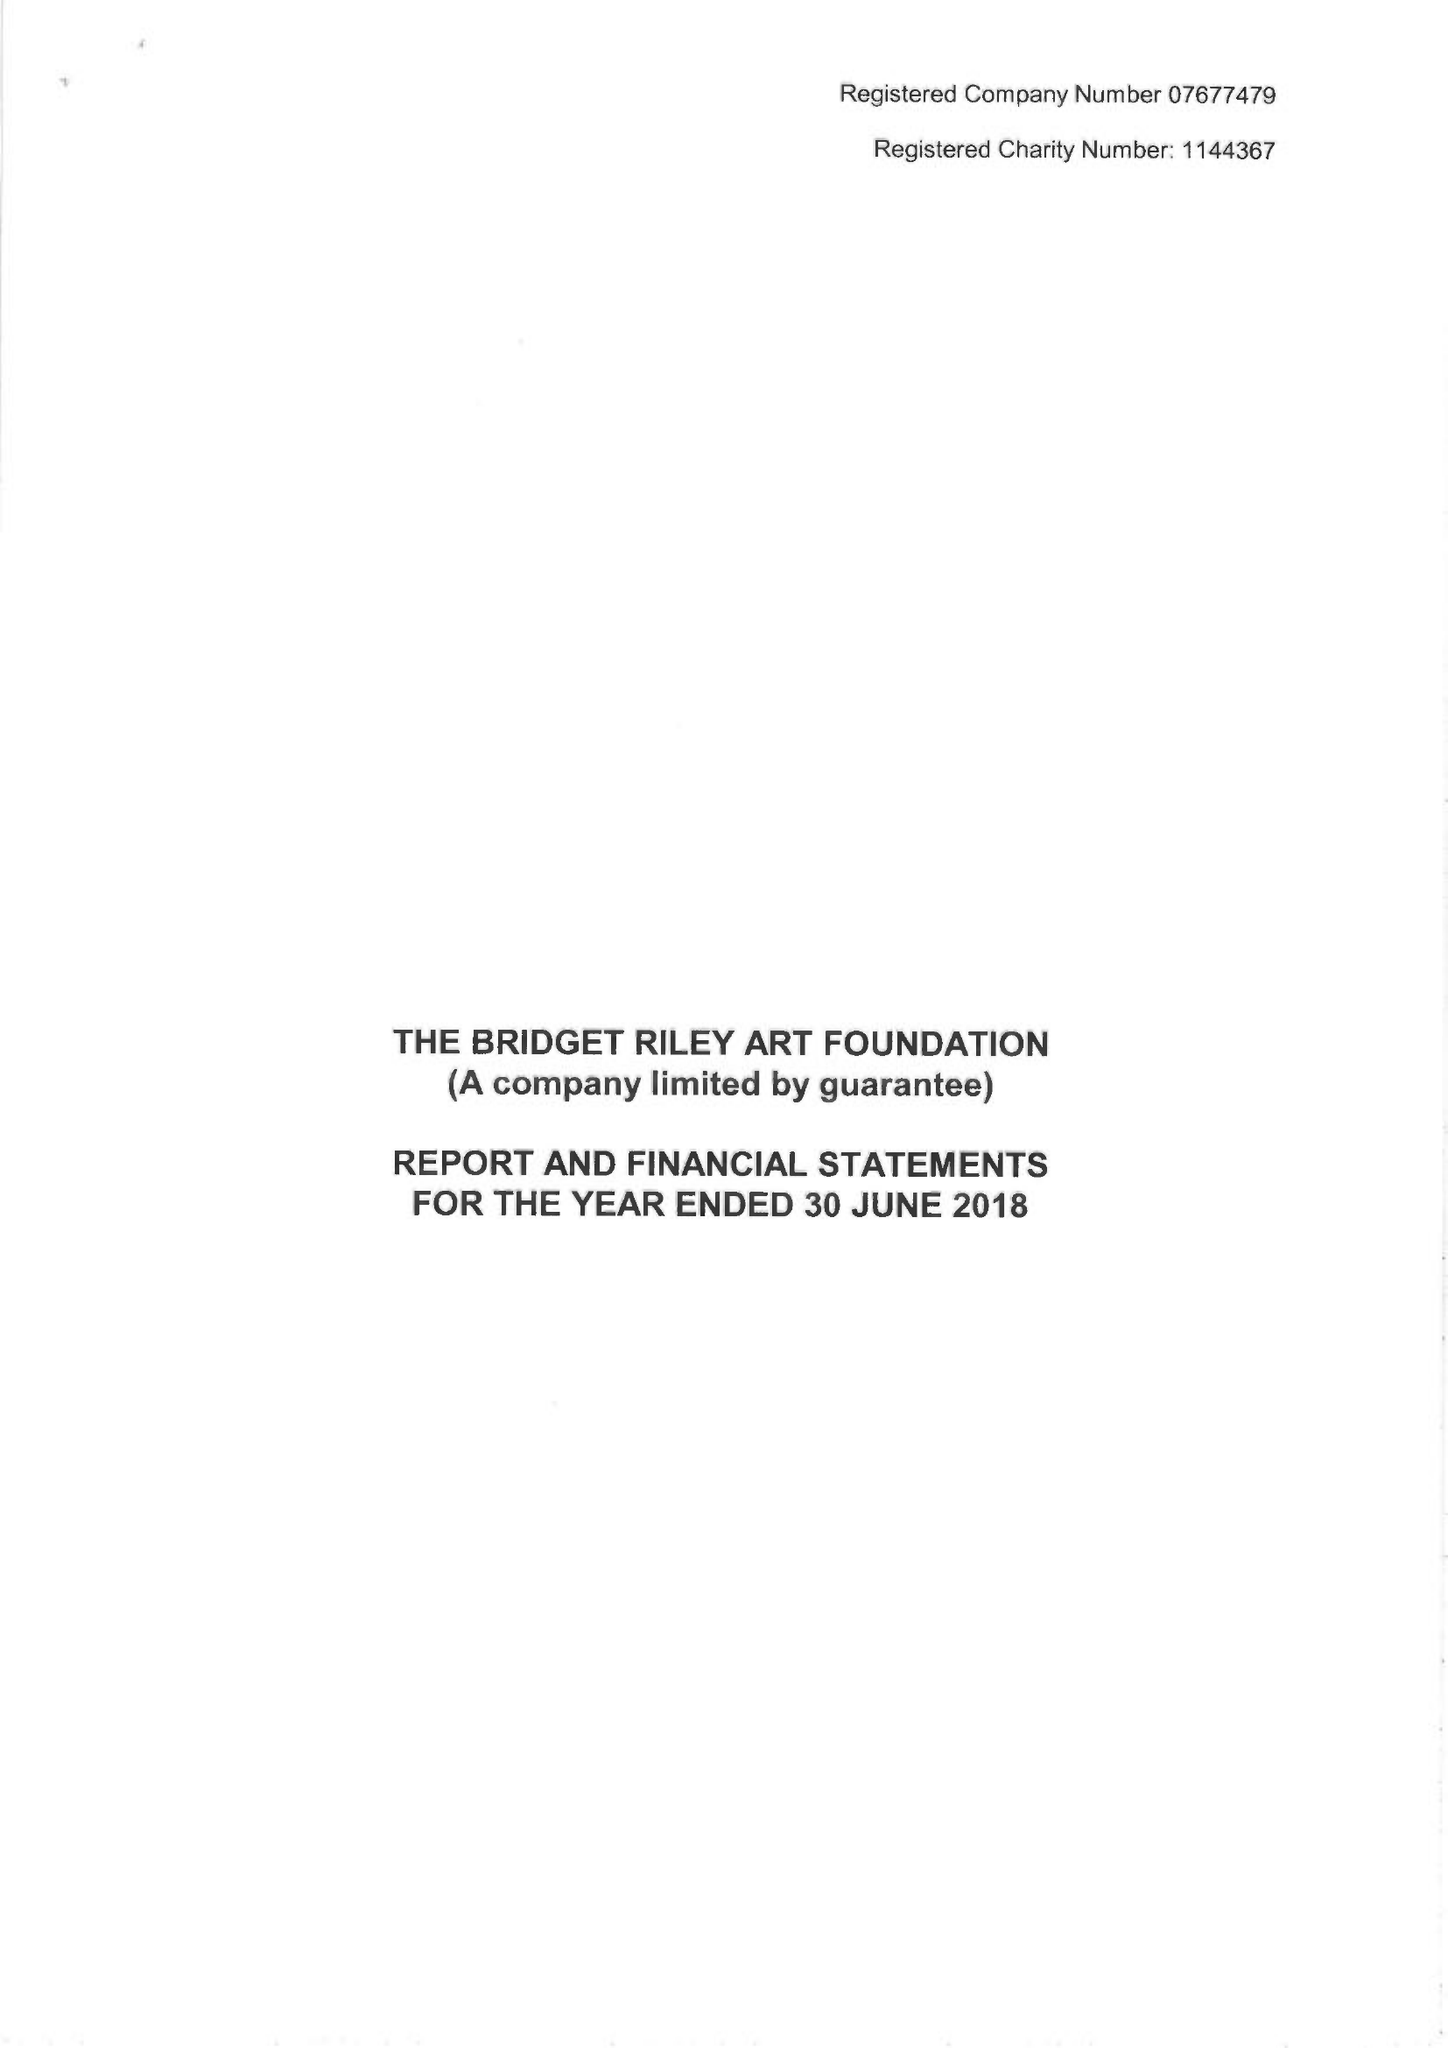What is the value for the address__street_line?
Answer the question using a single word or phrase. 7 ROYAL CRESCENT 